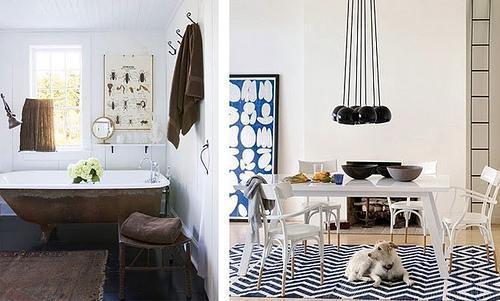How many rooms are shown?
Give a very brief answer. 2. How many chairs are there?
Give a very brief answer. 2. 